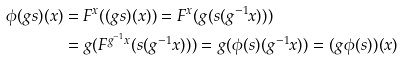<formula> <loc_0><loc_0><loc_500><loc_500>\phi ( g s ) ( x ) & = F ^ { x } ( ( g s ) ( x ) ) = F ^ { x } ( g ( s ( g ^ { - 1 } x ) ) ) \\ & = g ( F ^ { g ^ { - 1 } x } ( s ( g ^ { - 1 } x ) ) ) = g ( \phi ( s ) ( g ^ { - 1 } x ) ) = ( g \phi ( s ) ) ( x )</formula> 